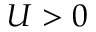Convert formula to latex. <formula><loc_0><loc_0><loc_500><loc_500>U > 0</formula> 